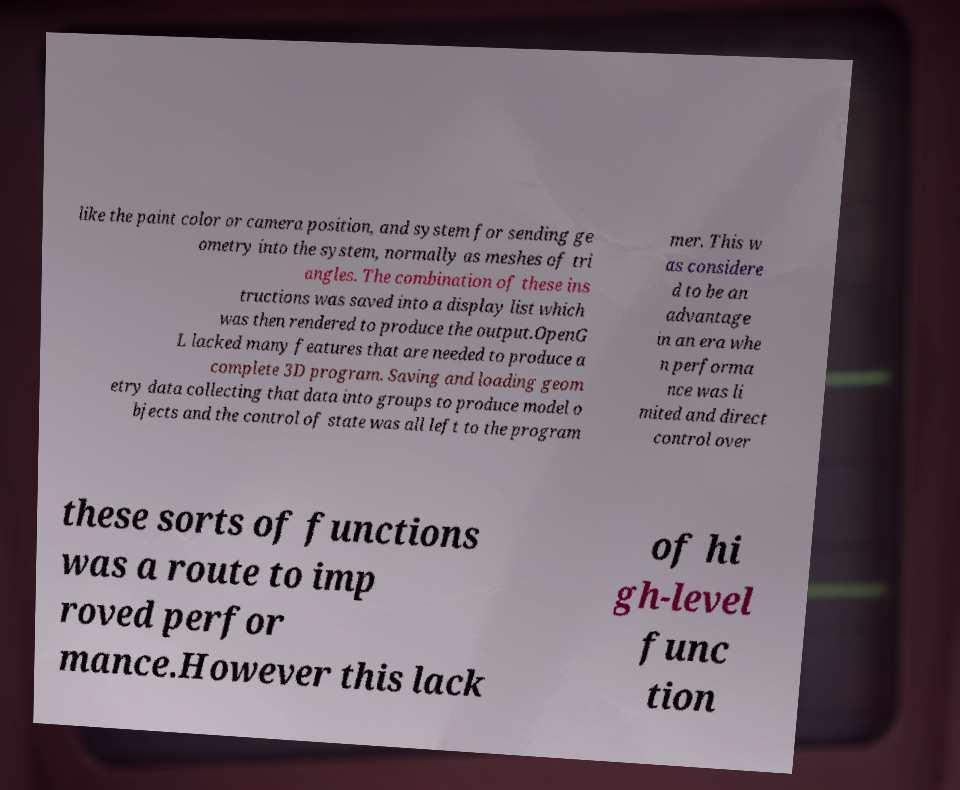Can you read and provide the text displayed in the image?This photo seems to have some interesting text. Can you extract and type it out for me? like the paint color or camera position, and system for sending ge ometry into the system, normally as meshes of tri angles. The combination of these ins tructions was saved into a display list which was then rendered to produce the output.OpenG L lacked many features that are needed to produce a complete 3D program. Saving and loading geom etry data collecting that data into groups to produce model o bjects and the control of state was all left to the program mer. This w as considere d to be an advantage in an era whe n performa nce was li mited and direct control over these sorts of functions was a route to imp roved perfor mance.However this lack of hi gh-level func tion 